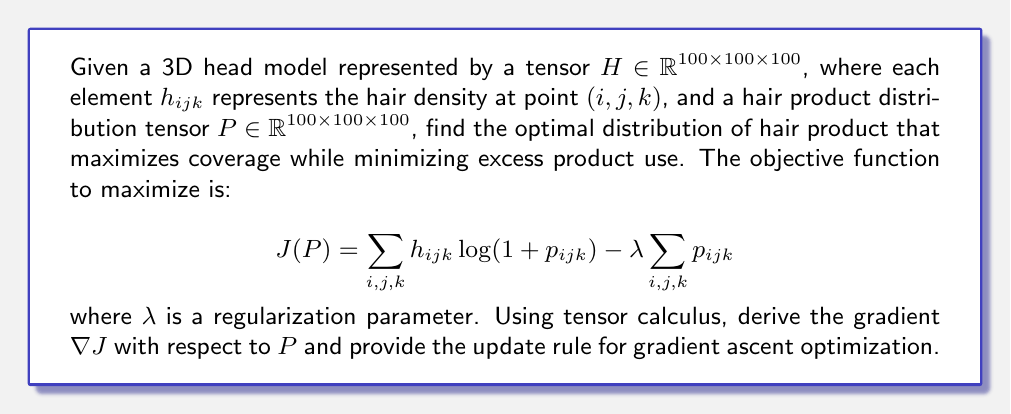Can you solve this math problem? To solve this problem, we'll follow these steps:

1) First, we need to calculate the gradient of $J$ with respect to $P$. This involves taking the partial derivative of $J$ with respect to each element $p_{ijk}$ of $P$.

2) The objective function $J(P)$ can be written as:

   $$J(P) = \sum_{i,j,k} h_{ijk} \log(1 + p_{ijk}) - \lambda \sum_{i,j,k} p_{ijk}$$

3) Taking the partial derivative with respect to $p_{ijk}$:

   $$\frac{\partial J}{\partial p_{ijk}} = \frac{h_{ijk}}{1 + p_{ijk}} - \lambda$$

4) The gradient $\nabla J$ is a tensor with the same dimensions as $P$, where each element is given by the partial derivative we just calculated:

   $$(\nabla J)_{ijk} = \frac{h_{ijk}}{1 + p_{ijk}} - \lambda$$

5) For gradient ascent optimization, we update $P$ in the direction of the gradient:

   $$P_{new} = P_{old} + \alpha \nabla J$$

   where $\alpha$ is the learning rate.

6) Elementwise, this update rule becomes:

   $$p_{ijk_{new}} = p_{ijk_{old}} + \alpha \left(\frac{h_{ijk}}{1 + p_{ijk_{old}}} - \lambda\right)$$

This update rule will iteratively adjust the product distribution to maximize coverage on areas with high hair density while minimizing overall product use.
Answer: $$(\nabla J)_{ijk} = \frac{h_{ijk}}{1 + p_{ijk}} - \lambda$$
$$p_{ijk_{new}} = p_{ijk_{old}} + \alpha \left(\frac{h_{ijk}}{1 + p_{ijk_{old}}} - \lambda\right)$$ 